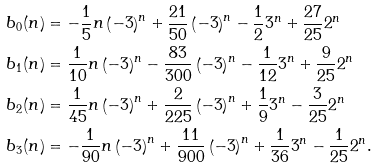<formula> <loc_0><loc_0><loc_500><loc_500>b _ { 0 } ( n ) & = - \frac { 1 } { 5 } n \left ( - 3 \right ) ^ { n } + \frac { 2 1 } { 5 0 } \left ( - 3 \right ) ^ { n } - \frac { 1 } { 2 } 3 ^ { n } + \frac { 2 7 } { 2 5 } 2 ^ { n } \\ b _ { 1 } ( n ) & = \frac { 1 } { 1 0 } n \left ( - 3 \right ) ^ { n } - \frac { 8 3 } { 3 0 0 } \left ( - 3 \right ) ^ { n } - \frac { 1 } { 1 2 } 3 ^ { n } + \frac { 9 } { 2 5 } 2 ^ { n } \\ b _ { 2 } ( n ) & = \frac { 1 } { 4 5 } n \left ( - 3 \right ) ^ { n } + \frac { 2 } { 2 2 5 } \left ( - 3 \right ) ^ { n } + \frac { 1 } { 9 } 3 ^ { n } - \frac { 3 } { 2 5 } 2 ^ { n } \\ b _ { 3 } ( n ) & = - \frac { 1 } { 9 0 } n \left ( - 3 \right ) ^ { n } + \frac { 1 1 } { 9 0 0 } \left ( - 3 \right ) ^ { n } + \frac { 1 } { 3 6 } 3 ^ { n } - \frac { 1 } { 2 5 } 2 ^ { n } .</formula> 